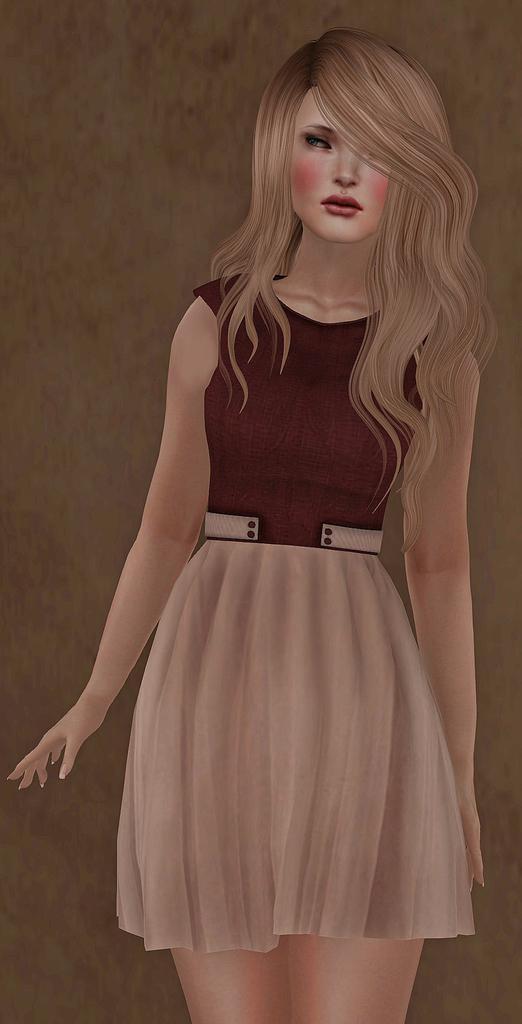Describe this image in one or two sentences. In this image we can see the animated picture of a person. 